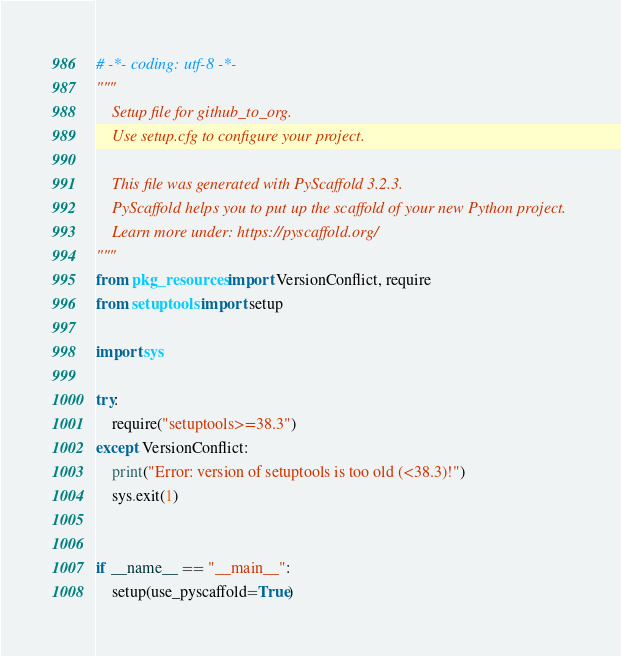<code> <loc_0><loc_0><loc_500><loc_500><_Python_># -*- coding: utf-8 -*-
"""
    Setup file for github_to_org.
    Use setup.cfg to configure your project.

    This file was generated with PyScaffold 3.2.3.
    PyScaffold helps you to put up the scaffold of your new Python project.
    Learn more under: https://pyscaffold.org/
"""
from pkg_resources import VersionConflict, require
from setuptools import setup

import sys

try:
    require("setuptools>=38.3")
except VersionConflict:
    print("Error: version of setuptools is too old (<38.3)!")
    sys.exit(1)


if __name__ == "__main__":
    setup(use_pyscaffold=True)
</code> 